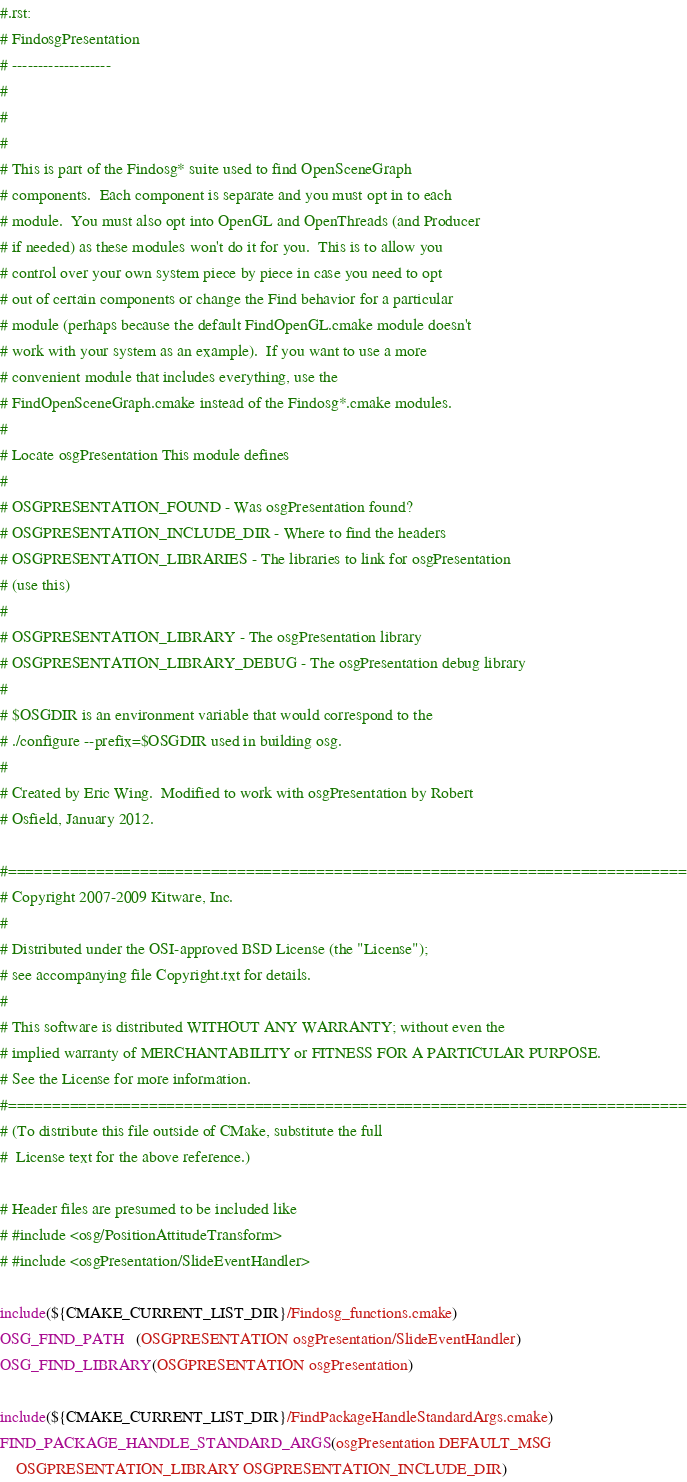Convert code to text. <code><loc_0><loc_0><loc_500><loc_500><_CMake_>#.rst:
# FindosgPresentation
# -------------------
#
#
#
# This is part of the Findosg* suite used to find OpenSceneGraph
# components.  Each component is separate and you must opt in to each
# module.  You must also opt into OpenGL and OpenThreads (and Producer
# if needed) as these modules won't do it for you.  This is to allow you
# control over your own system piece by piece in case you need to opt
# out of certain components or change the Find behavior for a particular
# module (perhaps because the default FindOpenGL.cmake module doesn't
# work with your system as an example).  If you want to use a more
# convenient module that includes everything, use the
# FindOpenSceneGraph.cmake instead of the Findosg*.cmake modules.
#
# Locate osgPresentation This module defines
#
# OSGPRESENTATION_FOUND - Was osgPresentation found?
# OSGPRESENTATION_INCLUDE_DIR - Where to find the headers
# OSGPRESENTATION_LIBRARIES - The libraries to link for osgPresentation
# (use this)
#
# OSGPRESENTATION_LIBRARY - The osgPresentation library
# OSGPRESENTATION_LIBRARY_DEBUG - The osgPresentation debug library
#
# $OSGDIR is an environment variable that would correspond to the
# ./configure --prefix=$OSGDIR used in building osg.
#
# Created by Eric Wing.  Modified to work with osgPresentation by Robert
# Osfield, January 2012.

#=============================================================================
# Copyright 2007-2009 Kitware, Inc.
#
# Distributed under the OSI-approved BSD License (the "License");
# see accompanying file Copyright.txt for details.
#
# This software is distributed WITHOUT ANY WARRANTY; without even the
# implied warranty of MERCHANTABILITY or FITNESS FOR A PARTICULAR PURPOSE.
# See the License for more information.
#=============================================================================
# (To distribute this file outside of CMake, substitute the full
#  License text for the above reference.)

# Header files are presumed to be included like
# #include <osg/PositionAttitudeTransform>
# #include <osgPresentation/SlideEventHandler>

include(${CMAKE_CURRENT_LIST_DIR}/Findosg_functions.cmake)
OSG_FIND_PATH   (OSGPRESENTATION osgPresentation/SlideEventHandler)
OSG_FIND_LIBRARY(OSGPRESENTATION osgPresentation)

include(${CMAKE_CURRENT_LIST_DIR}/FindPackageHandleStandardArgs.cmake)
FIND_PACKAGE_HANDLE_STANDARD_ARGS(osgPresentation DEFAULT_MSG
    OSGPRESENTATION_LIBRARY OSGPRESENTATION_INCLUDE_DIR)
</code> 